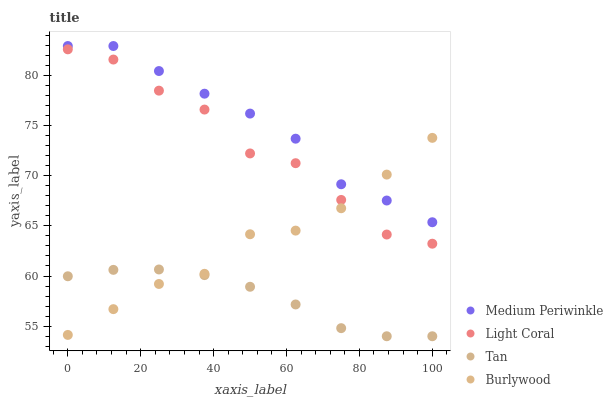Does Tan have the minimum area under the curve?
Answer yes or no. Yes. Does Medium Periwinkle have the maximum area under the curve?
Answer yes or no. Yes. Does Burlywood have the minimum area under the curve?
Answer yes or no. No. Does Burlywood have the maximum area under the curve?
Answer yes or no. No. Is Tan the smoothest?
Answer yes or no. Yes. Is Light Coral the roughest?
Answer yes or no. Yes. Is Burlywood the smoothest?
Answer yes or no. No. Is Burlywood the roughest?
Answer yes or no. No. Does Tan have the lowest value?
Answer yes or no. Yes. Does Burlywood have the lowest value?
Answer yes or no. No. Does Medium Periwinkle have the highest value?
Answer yes or no. Yes. Does Burlywood have the highest value?
Answer yes or no. No. Is Tan less than Medium Periwinkle?
Answer yes or no. Yes. Is Light Coral greater than Tan?
Answer yes or no. Yes. Does Tan intersect Burlywood?
Answer yes or no. Yes. Is Tan less than Burlywood?
Answer yes or no. No. Is Tan greater than Burlywood?
Answer yes or no. No. Does Tan intersect Medium Periwinkle?
Answer yes or no. No. 